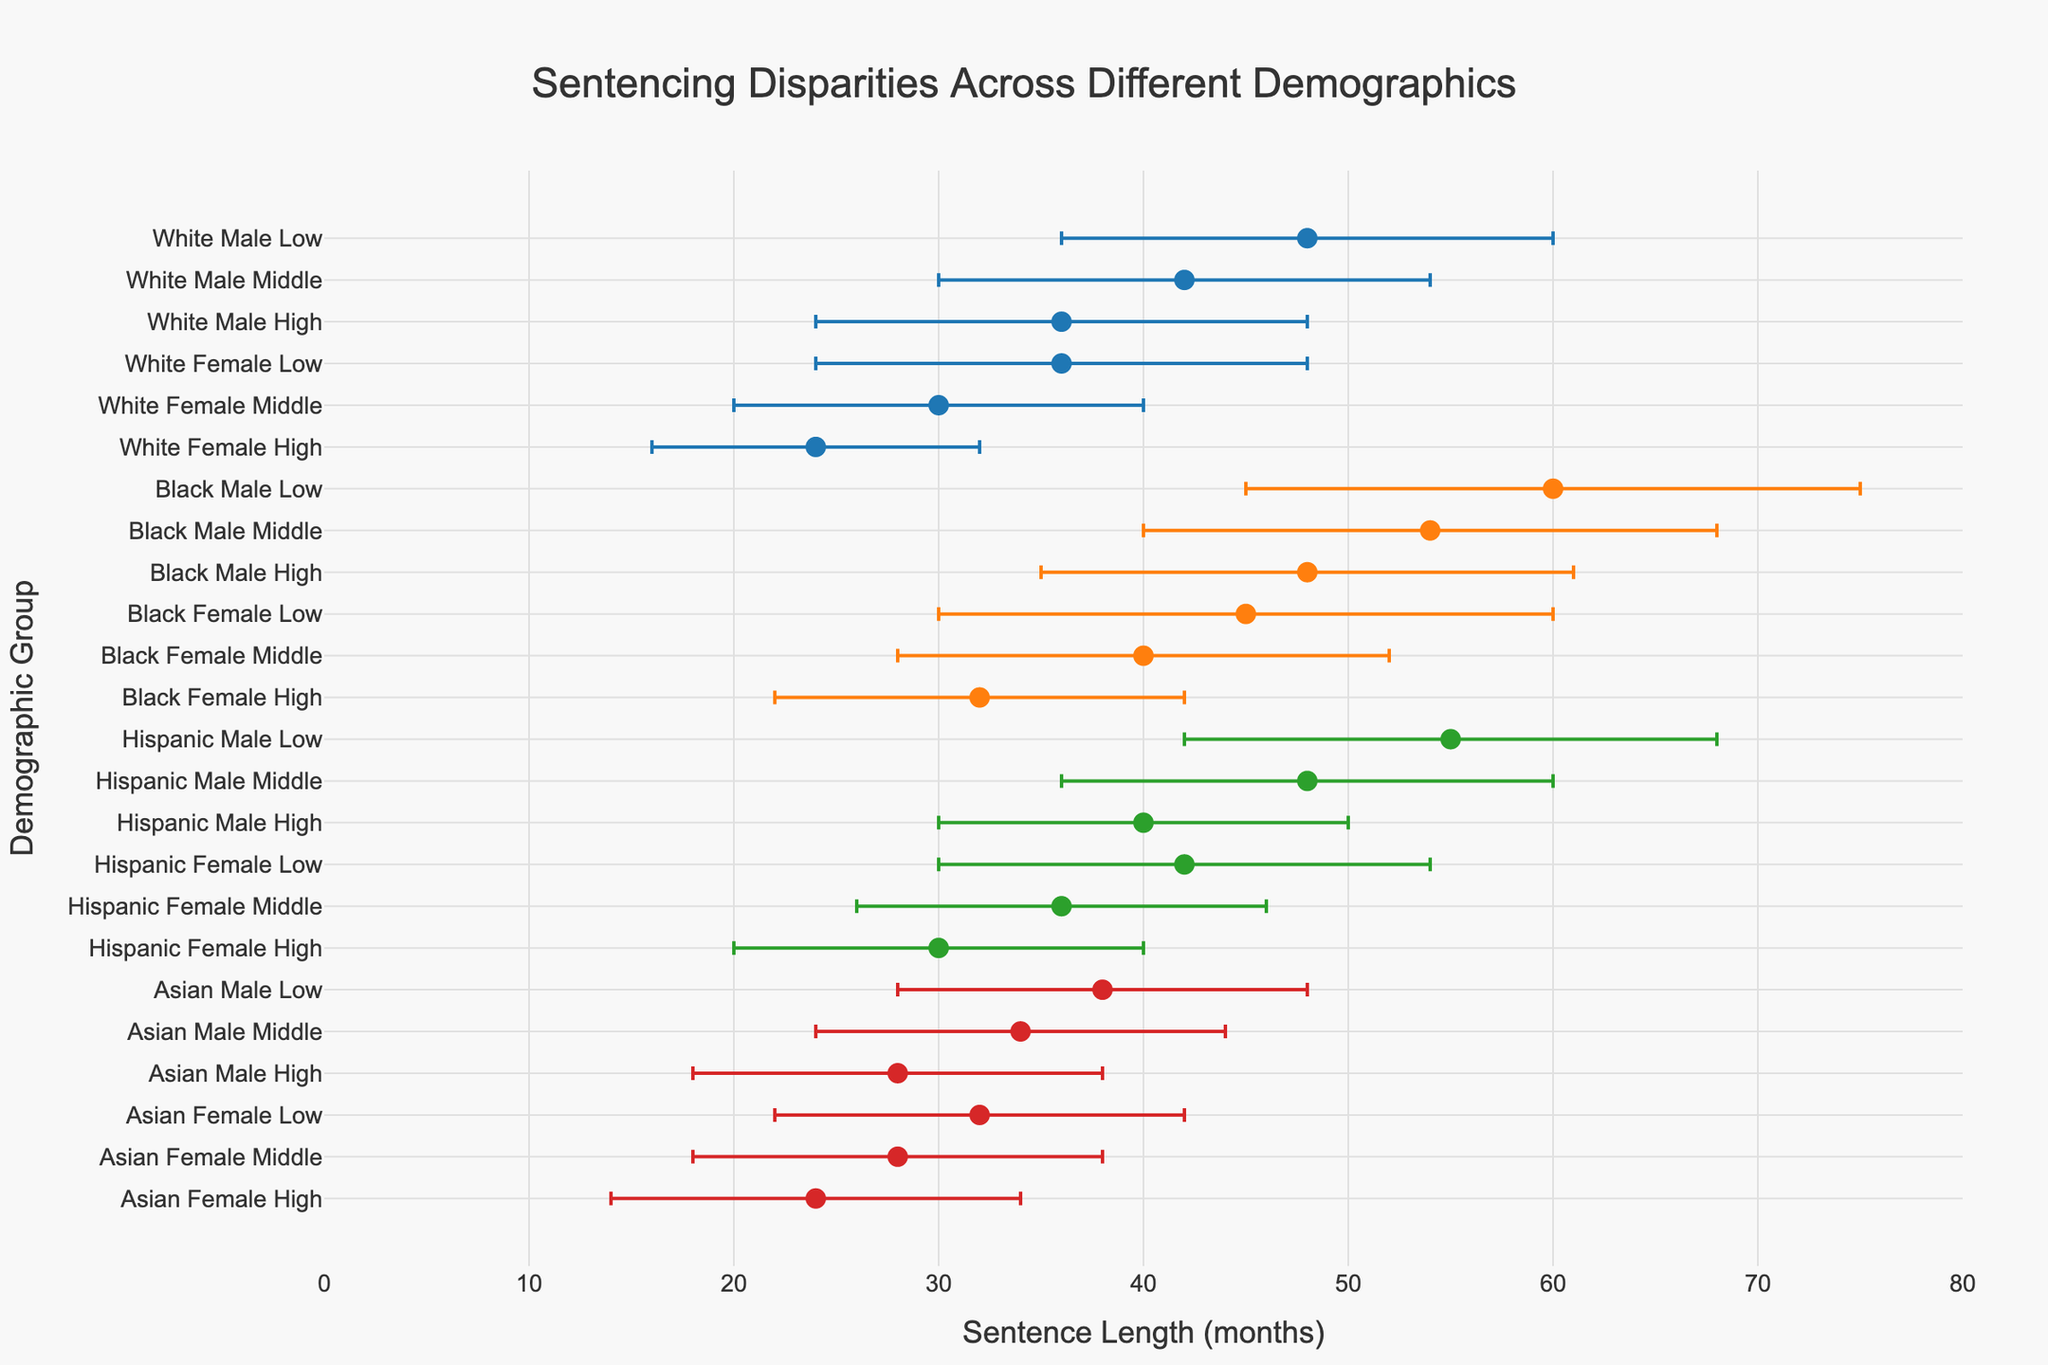What is the title of the figure? The title is typically displayed at the top of the figure. In this case, it is "Sentencing Disparities Across Different Demographics".
Answer: Sentencing Disparities Across Different Demographics How many demographic groups are plotted on the y-axis? Each unique combination of race, gender, and socioeconomic status forms a demographic group. There are four races, two genders, and three socioeconomic statuses, leading to a total of 4 * 2 * 3 = 24 demographic groups.
Answer: 24 Which group has the highest average sentence length? By identifying and comparing the average sentence lengths for all groups, the group "Black Male Low" has the highest average sentence length of 60 months.
Answer: Black Male Low What is the range of sentences for the "Hispanic Female Middle" group? Locate the point corresponding to "Hispanic Female Middle". The average sentence is 36 months, the minimum sentence is 26 months, and the maximum sentence is 46 months. The range is calculated as maximum - minimum = 46 - 26.
Answer: 20 months Which gender, on average, receives lower sentences within the "Asian" race? Compare the average sentences for "Asian Male" and "Asian Female" across all socioeconomic statuses. "Asian Female" consistently has lower average sentences than "Asian Male".
Answer: Asian Female What is the average sentence length for "White Female High" compared to "Black Female High"? The average sentence lengths are 24 months for "White Female High" and 32 months for "Black Female High". By comparing these values, the difference is 32 - 24.
Answer: 8 months How does socioeconomic status affect sentence length for "White Males"? Observe the trend across different socioeconomic statuses for "White Males". The average sentence lengths decrease as socioeconomic status increases: Low (48 months), Middle (42 months), High (36 months). This shows a negative correlation.
Answer: Higher status, lower sentences Which race has the most variability in sentence length for "Low" socioeconomic status? To determine variability, compare the ranges for each race at the "Low" socioeconomic status. "Black" has the range 75 - 45 = 30 months, which is the highest among all races for "Low" socioeconomic status.
Answer: Black Are sentences for "Hispanic Male Middle" more variable than those for "Asian Male High"? Compare the range of sentences for "Hispanic Male Middle" (60-36=24 months) to "Asian Male High" (38-18=20 months). The variability for "Hispanic Male Middle" is greater.
Answer: Yes What is the maximum sentence length for "Black Female Low" and how does it compare to "White Female Low"? "Black Female Low" has a maximum sentence of 60 months, while "White Female Low" has a maximum sentence of 48 months. Therefore, "Black Female Low" has a higher maximum sentence length.
Answer: 12 months longer 